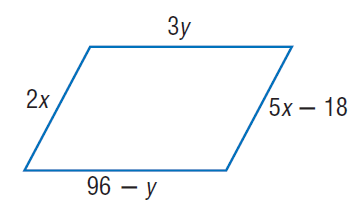Answer the mathemtical geometry problem and directly provide the correct option letter.
Question: Find y so that the quadrilateral is a parallelogram.
Choices: A: 12 B: 24 C: 48 D: 72 B 